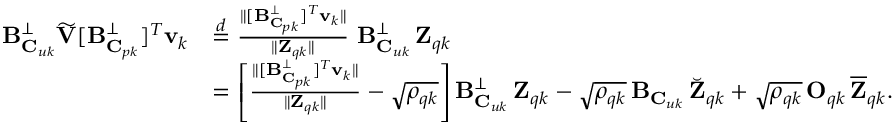Convert formula to latex. <formula><loc_0><loc_0><loc_500><loc_500>\begin{array} { r l } { B _ { C _ { u k } } ^ { \perp } \widetilde { V } [ B _ { C _ { p k } } ^ { \perp } ] ^ { T } v _ { k } } & { \stackrel { d } { = } \frac { \| [ B _ { C _ { p k } } ^ { \perp } ] ^ { T } v _ { k } \| } { \| Z _ { q k } \| } \, B _ { C _ { u k } } ^ { \perp } \, Z _ { q k } } \\ & { = \left [ \frac { \| [ B _ { C _ { p k } } ^ { \perp } ] ^ { T } v _ { k } \| } { \| Z _ { q k } \| } - \sqrt { \rho _ { q k } } \right ] B _ { C _ { u k } } ^ { \perp } \, Z _ { q k } - \sqrt { \rho _ { q k } } \, B _ { C _ { u k } } \, \breve { Z } _ { q k } + \sqrt { \rho _ { q k } } \, O _ { q k } \, \overline { Z } _ { q k } . } \end{array}</formula> 